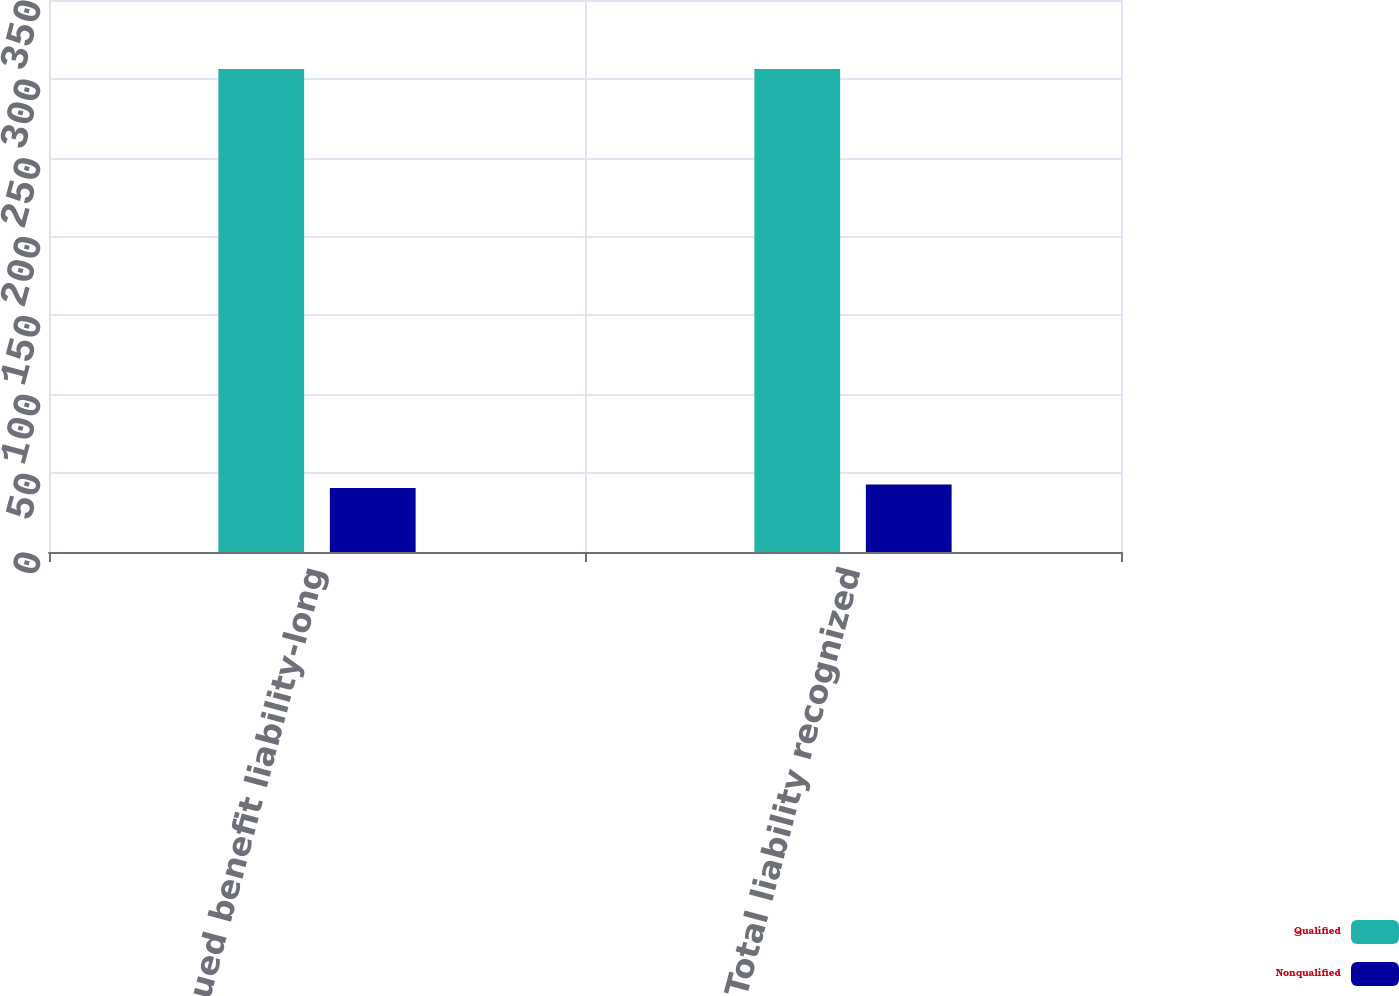Convert chart to OTSL. <chart><loc_0><loc_0><loc_500><loc_500><stacked_bar_chart><ecel><fcel>Accrued benefit liability-long<fcel>Total liability recognized<nl><fcel>Qualified<fcel>306.3<fcel>306.3<nl><fcel>Nonqualified<fcel>40.6<fcel>42.8<nl></chart> 